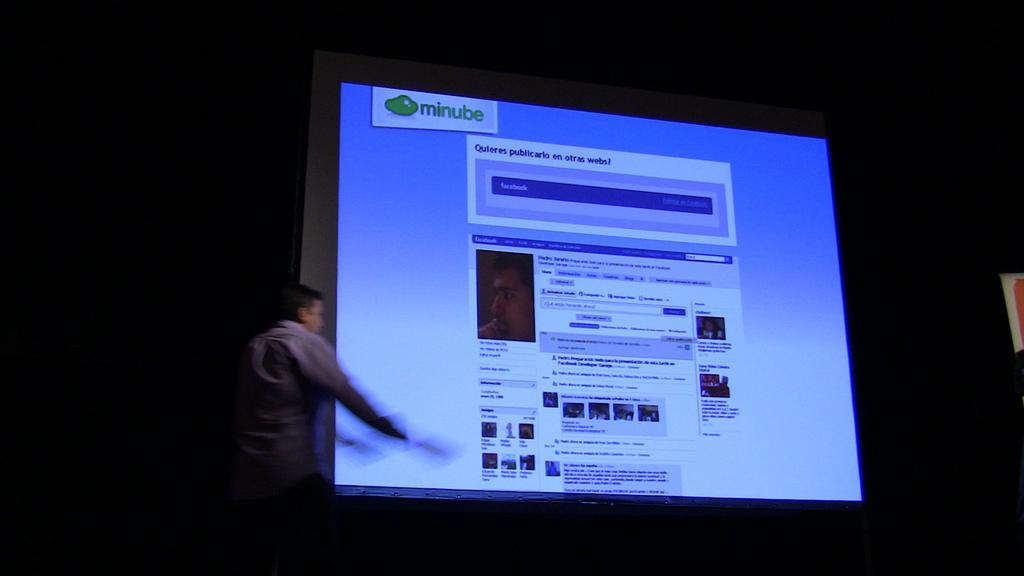<image>
Write a terse but informative summary of the picture. a computer screen with minube written to the top left 